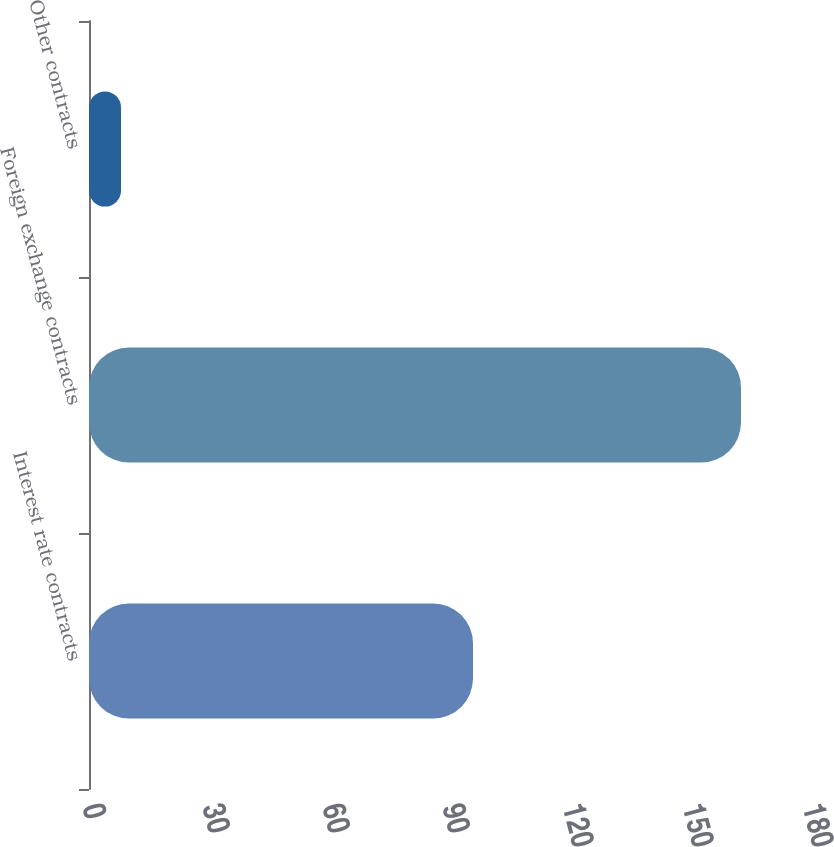Convert chart. <chart><loc_0><loc_0><loc_500><loc_500><bar_chart><fcel>Interest rate contracts<fcel>Foreign exchange contracts<fcel>Other contracts<nl><fcel>96<fcel>163<fcel>8<nl></chart> 